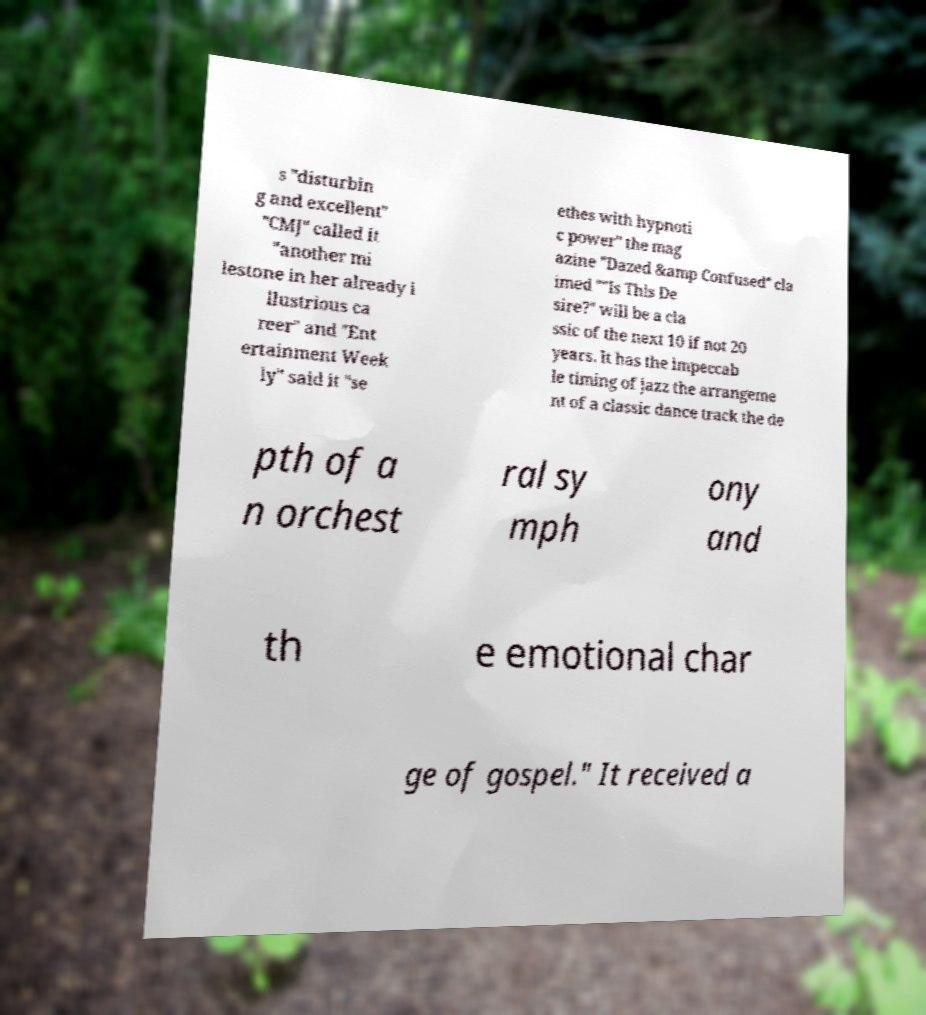Can you read and provide the text displayed in the image?This photo seems to have some interesting text. Can you extract and type it out for me? s "disturbin g and excellent" "CMJ" called it "another mi lestone in her already i llustrious ca reer" and "Ent ertainment Week ly" said it "se ethes with hypnoti c power" the mag azine "Dazed &amp Confused" cla imed ""Is This De sire?" will be a cla ssic of the next 10 if not 20 years. It has the impeccab le timing of jazz the arrangeme nt of a classic dance track the de pth of a n orchest ral sy mph ony and th e emotional char ge of gospel." It received a 